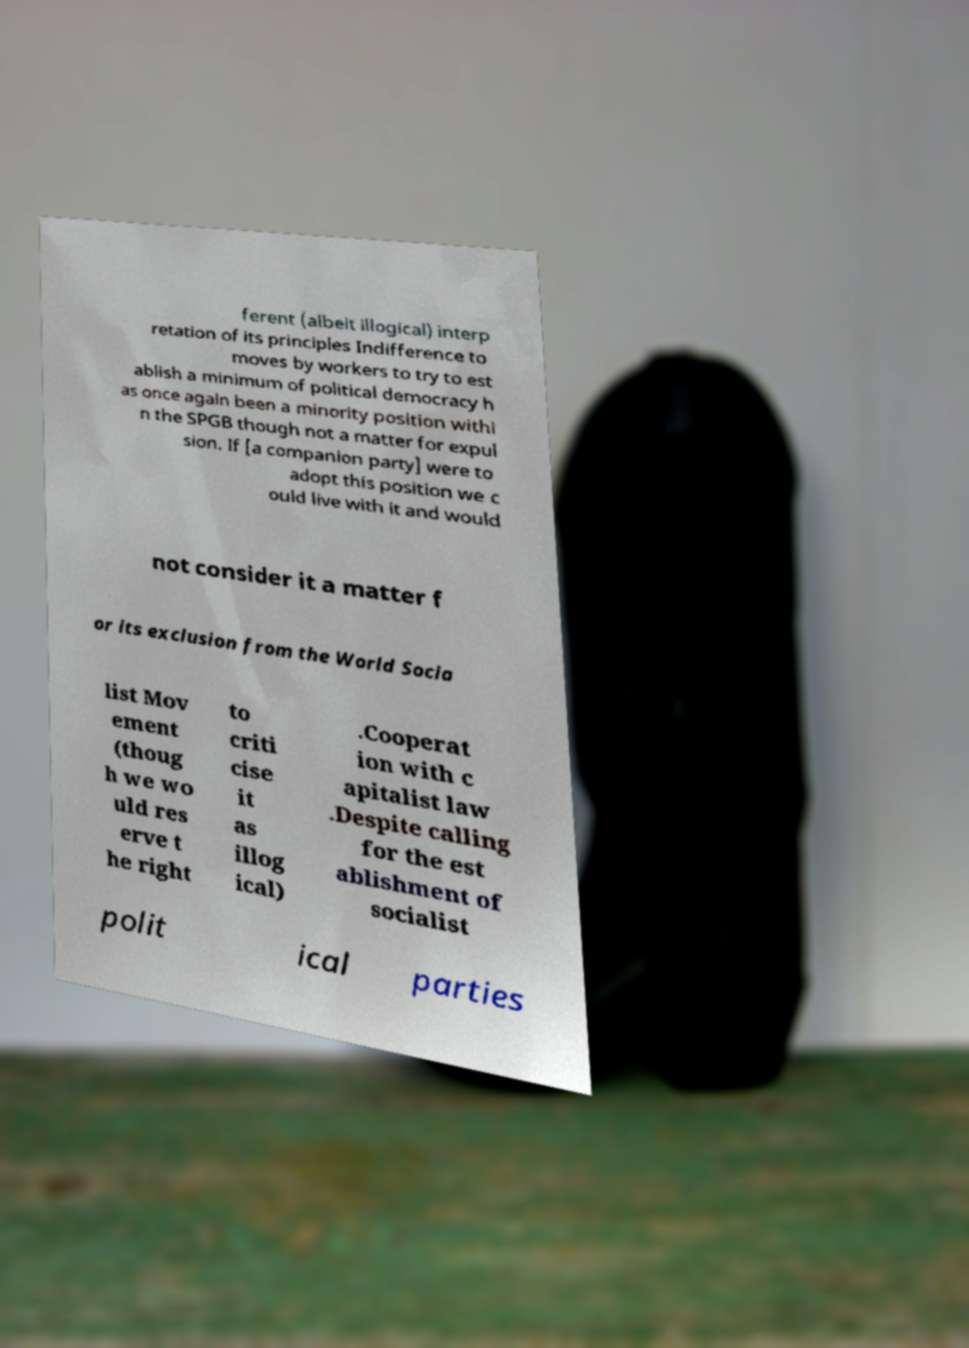There's text embedded in this image that I need extracted. Can you transcribe it verbatim? ferent (albeit illogical) interp retation of its principles Indifference to moves by workers to try to est ablish a minimum of political democracy h as once again been a minority position withi n the SPGB though not a matter for expul sion. If [a companion party] were to adopt this position we c ould live with it and would not consider it a matter f or its exclusion from the World Socia list Mov ement (thoug h we wo uld res erve t he right to criti cise it as illog ical) .Cooperat ion with c apitalist law .Despite calling for the est ablishment of socialist polit ical parties 